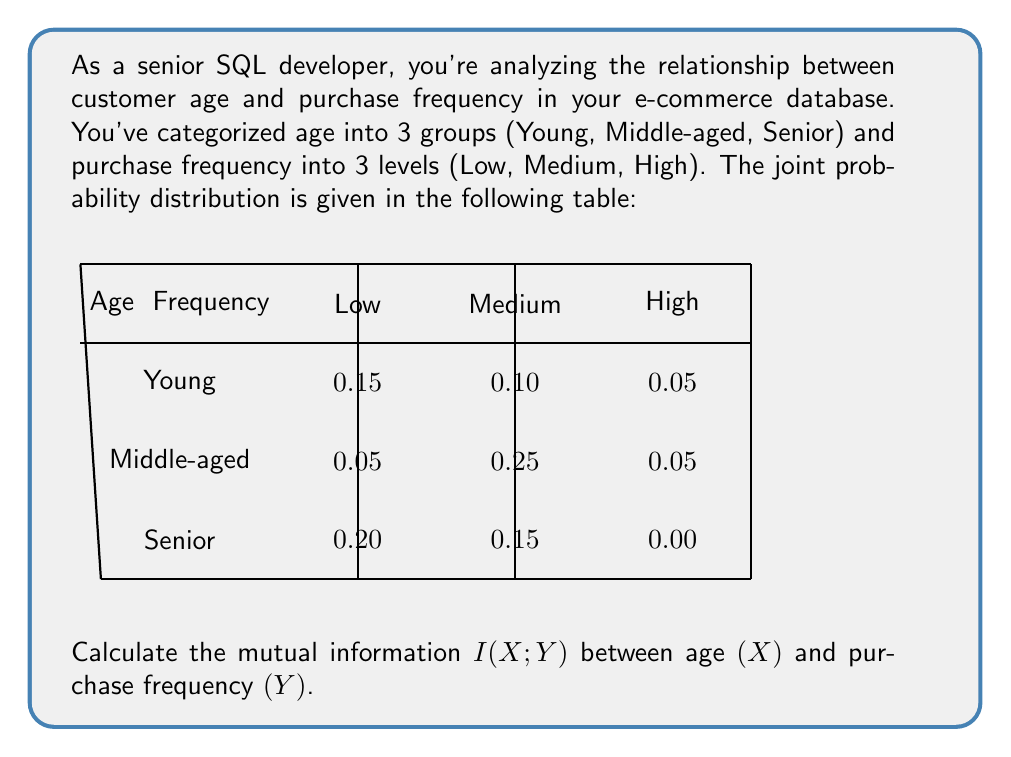What is the answer to this math problem? To calculate the mutual information $I(X;Y)$, we'll follow these steps:

1) First, we need to calculate the marginal probabilities:

   $P(X = \text{Young}) = 0.15 + 0.10 + 0.05 = 0.30$
   $P(X = \text{Middle-aged}) = 0.05 + 0.25 + 0.05 = 0.35$
   $P(X = \text{Senior}) = 0.20 + 0.15 + 0.00 = 0.35$

   $P(Y = \text{Low}) = 0.15 + 0.05 + 0.20 = 0.40$
   $P(Y = \text{Medium}) = 0.10 + 0.25 + 0.15 = 0.50$
   $P(Y = \text{High}) = 0.05 + 0.05 + 0.00 = 0.10$

2) The mutual information is defined as:

   $$I(X;Y) = \sum_{x \in X} \sum_{y \in Y} P(x,y) \log_2 \frac{P(x,y)}{P(x)P(y)}$$

3) Let's calculate each term:

   $0.15 \log_2 \frac{0.15}{0.30 \cdot 0.40} = 0.15 \log_2 1.25 = 0.0361$
   $0.10 \log_2 \frac{0.10}{0.30 \cdot 0.50} = 0.10 \log_2 0.67 = -0.0585$
   $0.05 \log_2 \frac{0.05}{0.30 \cdot 0.10} = 0.05 \log_2 1.67 = 0.0365$
   $0.05 \log_2 \frac{0.05}{0.35 \cdot 0.40} = 0.05 \log_2 0.36 = -0.0721$
   $0.25 \log_2 \frac{0.25}{0.35 \cdot 0.50} = 0.25 \log_2 1.43 = 0.1017$
   $0.05 \log_2 \frac{0.05}{0.35 \cdot 0.10} = 0.05 \log_2 1.43 = 0.0203$
   $0.20 \log_2 \frac{0.20}{0.35 \cdot 0.40} = 0.20 \log_2 1.43 = 0.0814$
   $0.15 \log_2 \frac{0.15}{0.35 \cdot 0.50} = 0.15 \log_2 0.86 = -0.0317$
   $0.00 \log_2 \frac{0.00}{0.35 \cdot 0.10} = 0$ (by convention, $0 \log 0 = 0$)

4) Sum all these terms:

   $I(X;Y) = 0.0361 - 0.0585 + 0.0365 - 0.0721 + 0.1017 + 0.0203 + 0.0814 - 0.0317 + 0 = 0.1137$

Therefore, the mutual information $I(X;Y)$ is approximately 0.1137 bits.
Answer: $I(X;Y) \approx 0.1137$ bits 